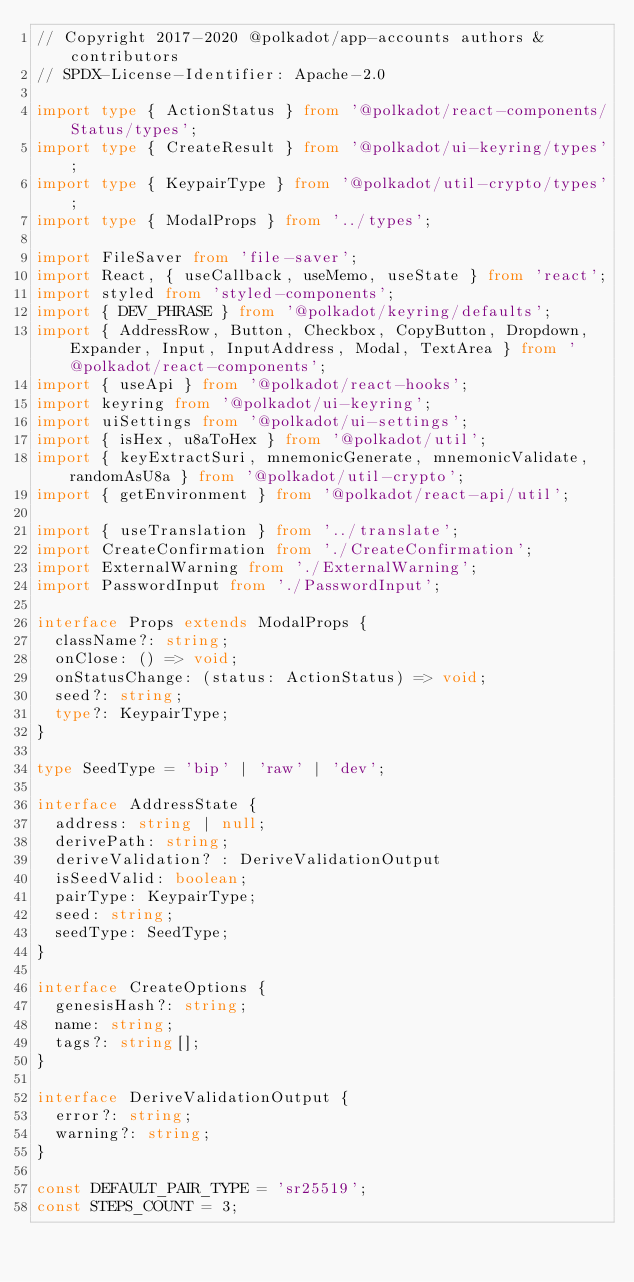<code> <loc_0><loc_0><loc_500><loc_500><_TypeScript_>// Copyright 2017-2020 @polkadot/app-accounts authors & contributors
// SPDX-License-Identifier: Apache-2.0

import type { ActionStatus } from '@polkadot/react-components/Status/types';
import type { CreateResult } from '@polkadot/ui-keyring/types';
import type { KeypairType } from '@polkadot/util-crypto/types';
import type { ModalProps } from '../types';

import FileSaver from 'file-saver';
import React, { useCallback, useMemo, useState } from 'react';
import styled from 'styled-components';
import { DEV_PHRASE } from '@polkadot/keyring/defaults';
import { AddressRow, Button, Checkbox, CopyButton, Dropdown, Expander, Input, InputAddress, Modal, TextArea } from '@polkadot/react-components';
import { useApi } from '@polkadot/react-hooks';
import keyring from '@polkadot/ui-keyring';
import uiSettings from '@polkadot/ui-settings';
import { isHex, u8aToHex } from '@polkadot/util';
import { keyExtractSuri, mnemonicGenerate, mnemonicValidate, randomAsU8a } from '@polkadot/util-crypto';
import { getEnvironment } from '@polkadot/react-api/util';

import { useTranslation } from '../translate';
import CreateConfirmation from './CreateConfirmation';
import ExternalWarning from './ExternalWarning';
import PasswordInput from './PasswordInput';

interface Props extends ModalProps {
  className?: string;
  onClose: () => void;
  onStatusChange: (status: ActionStatus) => void;
  seed?: string;
  type?: KeypairType;
}

type SeedType = 'bip' | 'raw' | 'dev';

interface AddressState {
  address: string | null;
  derivePath: string;
  deriveValidation? : DeriveValidationOutput
  isSeedValid: boolean;
  pairType: KeypairType;
  seed: string;
  seedType: SeedType;
}

interface CreateOptions {
  genesisHash?: string;
  name: string;
  tags?: string[];
}

interface DeriveValidationOutput {
  error?: string;
  warning?: string;
}

const DEFAULT_PAIR_TYPE = 'sr25519';
const STEPS_COUNT = 3;
</code> 